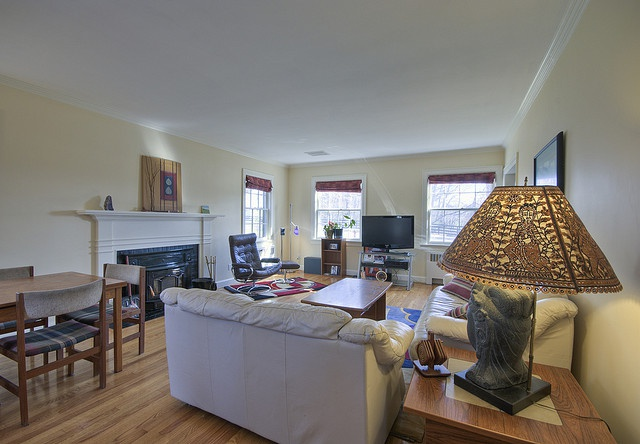Describe the objects in this image and their specific colors. I can see couch in gray and tan tones, chair in gray, black, and maroon tones, couch in gray, tan, darkgray, and olive tones, dining table in gray and maroon tones, and chair in gray, black, and maroon tones in this image. 